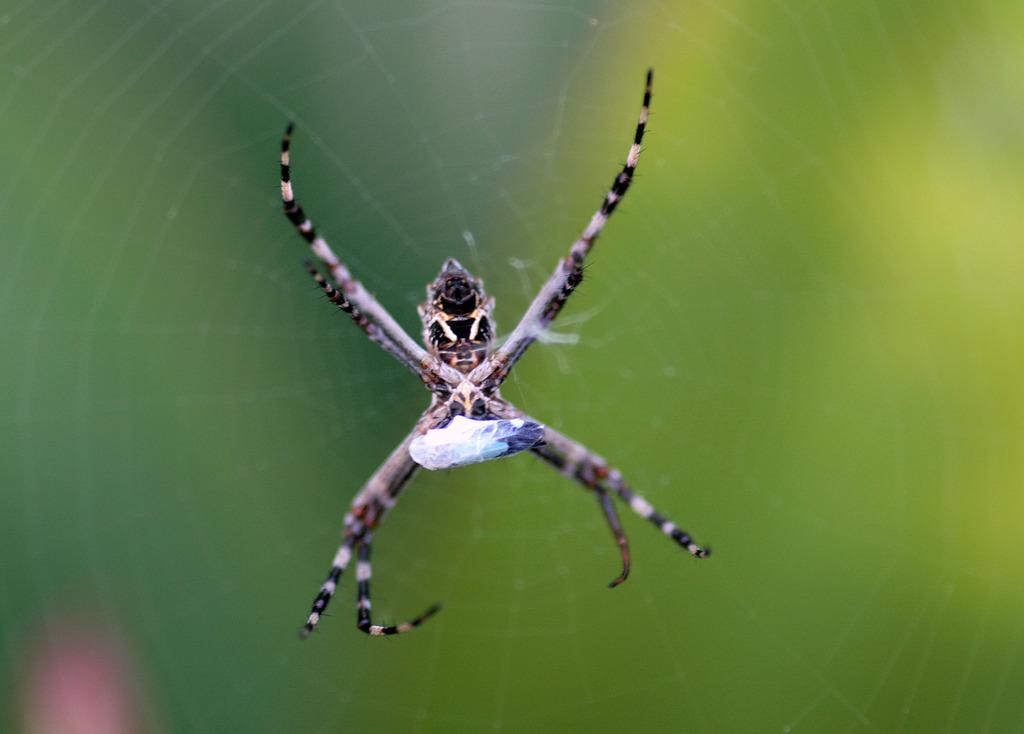What is the main subject in the foreground of the image? There is a spider in the foreground of the image. What is the spider doing or situated on in the image? The spider is on a spider web. What type of pig can be seen carrying a pocket in the image? There is no pig or pocket present in the image; it features a spider on a spider web. What type of plough is being used by the spider in the image? There is no plough present in the image; it features a spider on a spider web. 